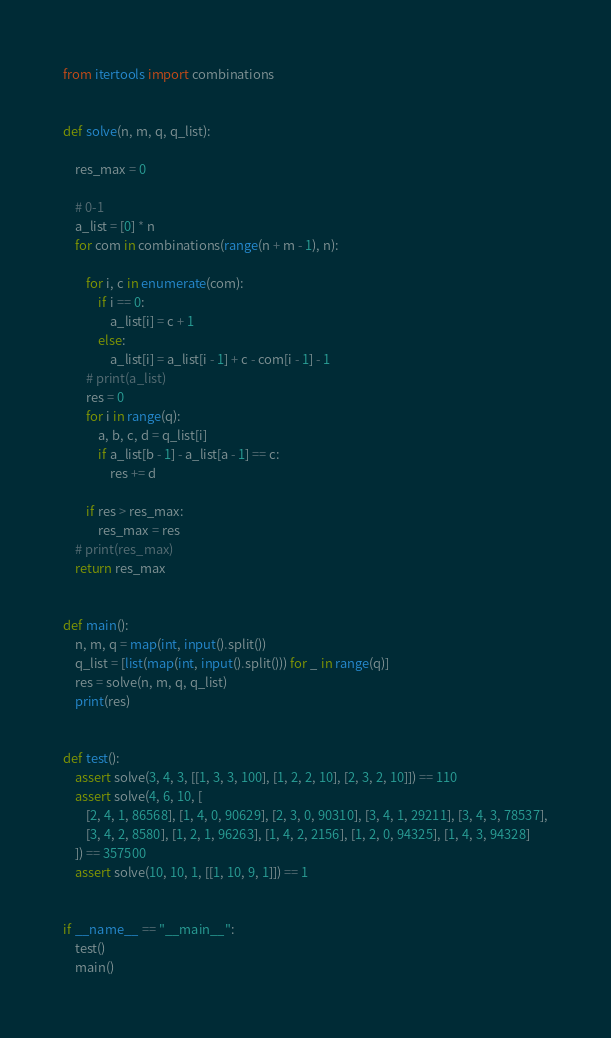Convert code to text. <code><loc_0><loc_0><loc_500><loc_500><_Python_>from itertools import combinations


def solve(n, m, q, q_list):

    res_max = 0

    # 0-1
    a_list = [0] * n
    for com in combinations(range(n + m - 1), n):

        for i, c in enumerate(com):
            if i == 0:
                a_list[i] = c + 1
            else:
                a_list[i] = a_list[i - 1] + c - com[i - 1] - 1
        # print(a_list)
        res = 0
        for i in range(q):
            a, b, c, d = q_list[i]
            if a_list[b - 1] - a_list[a - 1] == c:
                res += d

        if res > res_max:
            res_max = res
    # print(res_max)
    return res_max


def main():
    n, m, q = map(int, input().split())
    q_list = [list(map(int, input().split())) for _ in range(q)]
    res = solve(n, m, q, q_list)
    print(res)


def test():
    assert solve(3, 4, 3, [[1, 3, 3, 100], [1, 2, 2, 10], [2, 3, 2, 10]]) == 110
    assert solve(4, 6, 10, [
        [2, 4, 1, 86568], [1, 4, 0, 90629], [2, 3, 0, 90310], [3, 4, 1, 29211], [3, 4, 3, 78537],
        [3, 4, 2, 8580], [1, 2, 1, 96263], [1, 4, 2, 2156], [1, 2, 0, 94325], [1, 4, 3, 94328]
    ]) == 357500
    assert solve(10, 10, 1, [[1, 10, 9, 1]]) == 1


if __name__ == "__main__":
    test()
    main()
</code> 